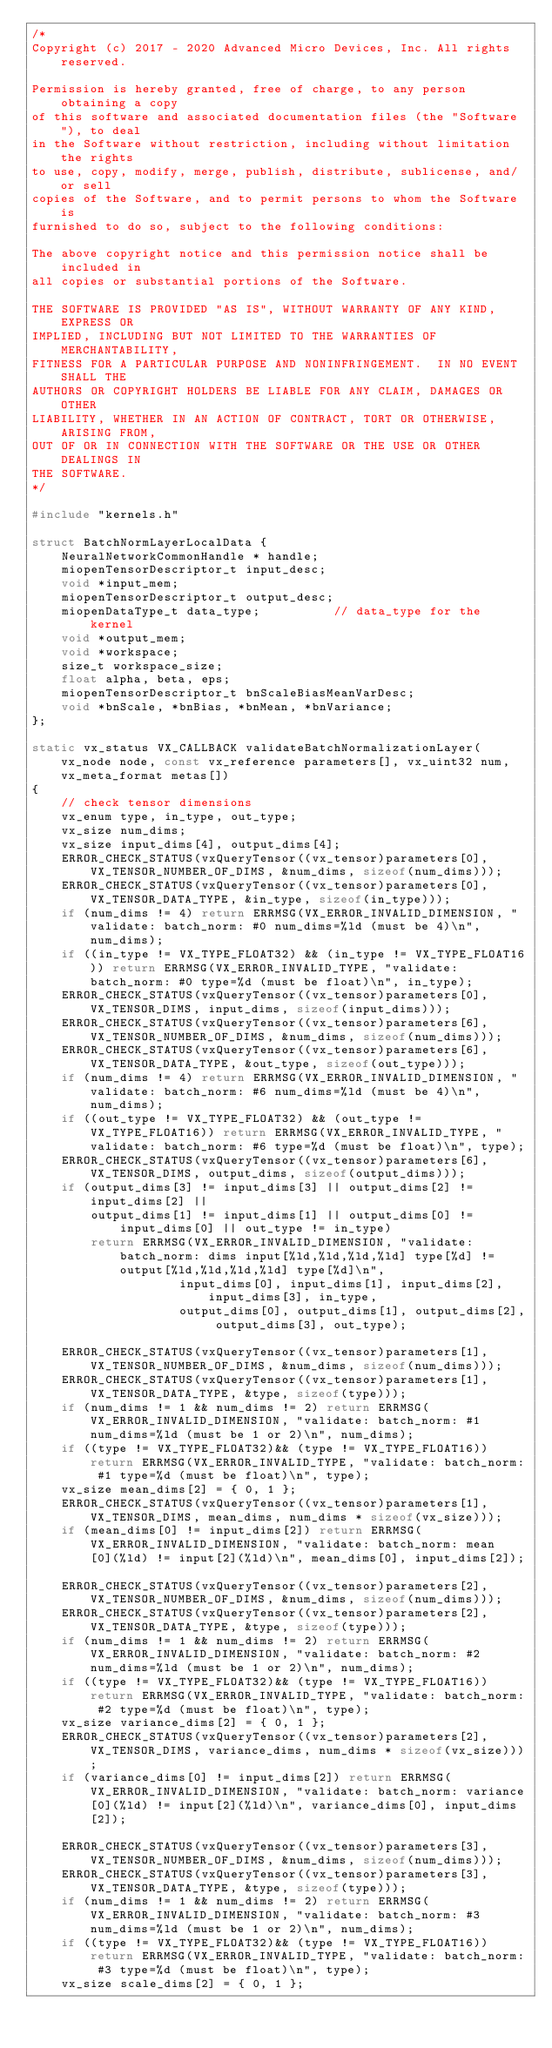Convert code to text. <code><loc_0><loc_0><loc_500><loc_500><_C++_>/*
Copyright (c) 2017 - 2020 Advanced Micro Devices, Inc. All rights reserved.

Permission is hereby granted, free of charge, to any person obtaining a copy
of this software and associated documentation files (the "Software"), to deal
in the Software without restriction, including without limitation the rights
to use, copy, modify, merge, publish, distribute, sublicense, and/or sell
copies of the Software, and to permit persons to whom the Software is
furnished to do so, subject to the following conditions:

The above copyright notice and this permission notice shall be included in
all copies or substantial portions of the Software.

THE SOFTWARE IS PROVIDED "AS IS", WITHOUT WARRANTY OF ANY KIND, EXPRESS OR
IMPLIED, INCLUDING BUT NOT LIMITED TO THE WARRANTIES OF MERCHANTABILITY,
FITNESS FOR A PARTICULAR PURPOSE AND NONINFRINGEMENT.  IN NO EVENT SHALL THE
AUTHORS OR COPYRIGHT HOLDERS BE LIABLE FOR ANY CLAIM, DAMAGES OR OTHER
LIABILITY, WHETHER IN AN ACTION OF CONTRACT, TORT OR OTHERWISE, ARISING FROM,
OUT OF OR IN CONNECTION WITH THE SOFTWARE OR THE USE OR OTHER DEALINGS IN
THE SOFTWARE.
*/

#include "kernels.h"

struct BatchNormLayerLocalData {
    NeuralNetworkCommonHandle * handle;
    miopenTensorDescriptor_t input_desc;
    void *input_mem;
    miopenTensorDescriptor_t output_desc;
    miopenDataType_t data_type;          // data_type for the kernel
    void *output_mem;
    void *workspace;
    size_t workspace_size;
    float alpha, beta, eps;
    miopenTensorDescriptor_t bnScaleBiasMeanVarDesc;
    void *bnScale, *bnBias, *bnMean, *bnVariance;
};

static vx_status VX_CALLBACK validateBatchNormalizationLayer(vx_node node, const vx_reference parameters[], vx_uint32 num, vx_meta_format metas[])
{
    // check tensor dimensions
    vx_enum type, in_type, out_type;
    vx_size num_dims;
    vx_size input_dims[4], output_dims[4];
    ERROR_CHECK_STATUS(vxQueryTensor((vx_tensor)parameters[0], VX_TENSOR_NUMBER_OF_DIMS, &num_dims, sizeof(num_dims)));
    ERROR_CHECK_STATUS(vxQueryTensor((vx_tensor)parameters[0], VX_TENSOR_DATA_TYPE, &in_type, sizeof(in_type)));
    if (num_dims != 4) return ERRMSG(VX_ERROR_INVALID_DIMENSION, "validate: batch_norm: #0 num_dims=%ld (must be 4)\n", num_dims);
    if ((in_type != VX_TYPE_FLOAT32) && (in_type != VX_TYPE_FLOAT16)) return ERRMSG(VX_ERROR_INVALID_TYPE, "validate: batch_norm: #0 type=%d (must be float)\n", in_type);
    ERROR_CHECK_STATUS(vxQueryTensor((vx_tensor)parameters[0], VX_TENSOR_DIMS, input_dims, sizeof(input_dims)));
    ERROR_CHECK_STATUS(vxQueryTensor((vx_tensor)parameters[6], VX_TENSOR_NUMBER_OF_DIMS, &num_dims, sizeof(num_dims)));
    ERROR_CHECK_STATUS(vxQueryTensor((vx_tensor)parameters[6], VX_TENSOR_DATA_TYPE, &out_type, sizeof(out_type)));
    if (num_dims != 4) return ERRMSG(VX_ERROR_INVALID_DIMENSION, "validate: batch_norm: #6 num_dims=%ld (must be 4)\n", num_dims);
    if ((out_type != VX_TYPE_FLOAT32) && (out_type != VX_TYPE_FLOAT16)) return ERRMSG(VX_ERROR_INVALID_TYPE, "validate: batch_norm: #6 type=%d (must be float)\n", type);
    ERROR_CHECK_STATUS(vxQueryTensor((vx_tensor)parameters[6], VX_TENSOR_DIMS, output_dims, sizeof(output_dims)));
    if (output_dims[3] != input_dims[3] || output_dims[2] != input_dims[2] ||
        output_dims[1] != input_dims[1] || output_dims[0] != input_dims[0] || out_type != in_type)
        return ERRMSG(VX_ERROR_INVALID_DIMENSION, "validate: batch_norm: dims input[%ld,%ld,%ld,%ld] type[%d] != output[%ld,%ld,%ld,%ld] type[%d]\n",
                    input_dims[0], input_dims[1], input_dims[2], input_dims[3], in_type,
                    output_dims[0], output_dims[1], output_dims[2], output_dims[3], out_type);

    ERROR_CHECK_STATUS(vxQueryTensor((vx_tensor)parameters[1], VX_TENSOR_NUMBER_OF_DIMS, &num_dims, sizeof(num_dims)));
    ERROR_CHECK_STATUS(vxQueryTensor((vx_tensor)parameters[1], VX_TENSOR_DATA_TYPE, &type, sizeof(type)));
    if (num_dims != 1 && num_dims != 2) return ERRMSG(VX_ERROR_INVALID_DIMENSION, "validate: batch_norm: #1 num_dims=%ld (must be 1 or 2)\n", num_dims);
    if ((type != VX_TYPE_FLOAT32)&& (type != VX_TYPE_FLOAT16)) return ERRMSG(VX_ERROR_INVALID_TYPE, "validate: batch_norm: #1 type=%d (must be float)\n", type);
    vx_size mean_dims[2] = { 0, 1 };
    ERROR_CHECK_STATUS(vxQueryTensor((vx_tensor)parameters[1], VX_TENSOR_DIMS, mean_dims, num_dims * sizeof(vx_size)));
    if (mean_dims[0] != input_dims[2]) return ERRMSG(VX_ERROR_INVALID_DIMENSION, "validate: batch_norm: mean[0](%ld) != input[2](%ld)\n", mean_dims[0], input_dims[2]);

    ERROR_CHECK_STATUS(vxQueryTensor((vx_tensor)parameters[2], VX_TENSOR_NUMBER_OF_DIMS, &num_dims, sizeof(num_dims)));
    ERROR_CHECK_STATUS(vxQueryTensor((vx_tensor)parameters[2], VX_TENSOR_DATA_TYPE, &type, sizeof(type)));
    if (num_dims != 1 && num_dims != 2) return ERRMSG(VX_ERROR_INVALID_DIMENSION, "validate: batch_norm: #2 num_dims=%ld (must be 1 or 2)\n", num_dims);
    if ((type != VX_TYPE_FLOAT32)&& (type != VX_TYPE_FLOAT16)) return ERRMSG(VX_ERROR_INVALID_TYPE, "validate: batch_norm: #2 type=%d (must be float)\n", type);
    vx_size variance_dims[2] = { 0, 1 };
    ERROR_CHECK_STATUS(vxQueryTensor((vx_tensor)parameters[2], VX_TENSOR_DIMS, variance_dims, num_dims * sizeof(vx_size)));
    if (variance_dims[0] != input_dims[2]) return ERRMSG(VX_ERROR_INVALID_DIMENSION, "validate: batch_norm: variance[0](%ld) != input[2](%ld)\n", variance_dims[0], input_dims[2]);

    ERROR_CHECK_STATUS(vxQueryTensor((vx_tensor)parameters[3], VX_TENSOR_NUMBER_OF_DIMS, &num_dims, sizeof(num_dims)));
    ERROR_CHECK_STATUS(vxQueryTensor((vx_tensor)parameters[3], VX_TENSOR_DATA_TYPE, &type, sizeof(type)));
    if (num_dims != 1 && num_dims != 2) return ERRMSG(VX_ERROR_INVALID_DIMENSION, "validate: batch_norm: #3 num_dims=%ld (must be 1 or 2)\n", num_dims);
    if ((type != VX_TYPE_FLOAT32)&& (type != VX_TYPE_FLOAT16)) return ERRMSG(VX_ERROR_INVALID_TYPE, "validate: batch_norm: #3 type=%d (must be float)\n", type);
    vx_size scale_dims[2] = { 0, 1 };</code> 